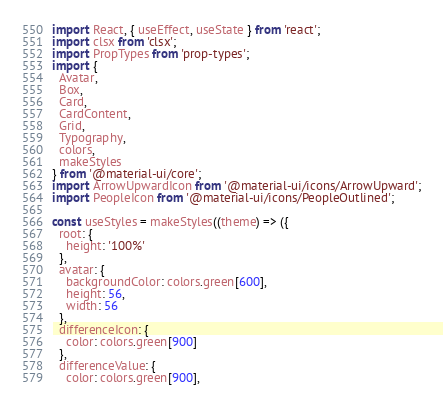<code> <loc_0><loc_0><loc_500><loc_500><_JavaScript_>import React, { useEffect, useState } from 'react';
import clsx from 'clsx';
import PropTypes from 'prop-types';
import {
  Avatar,
  Box,
  Card,
  CardContent,
  Grid,
  Typography,
  colors,
  makeStyles
} from '@material-ui/core';
import ArrowUpwardIcon from '@material-ui/icons/ArrowUpward';
import PeopleIcon from '@material-ui/icons/PeopleOutlined';

const useStyles = makeStyles((theme) => ({
  root: {
    height: '100%'
  },
  avatar: {
    backgroundColor: colors.green[600],
    height: 56,
    width: 56
  },
  differenceIcon: {
    color: colors.green[900]
  },
  differenceValue: {
    color: colors.green[900],</code> 